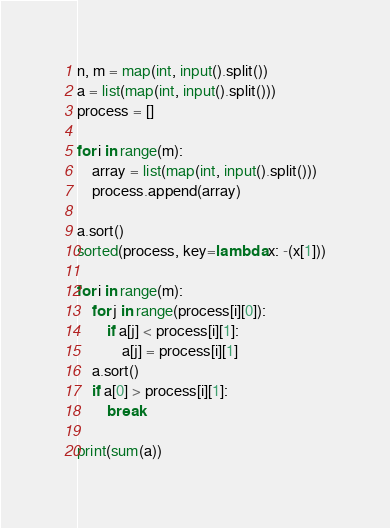<code> <loc_0><loc_0><loc_500><loc_500><_Python_>n, m = map(int, input().split())
a = list(map(int, input().split()))
process = []

for i in range(m):
    array = list(map(int, input().split()))
    process.append(array)

a.sort()
sorted(process, key=lambda x: -(x[1]))

for i in range(m):
    for j in range(process[i][0]):
        if a[j] < process[i][1]:
            a[j] = process[i][1]
    a.sort()
    if a[0] > process[i][1]:
        break

print(sum(a))
</code> 